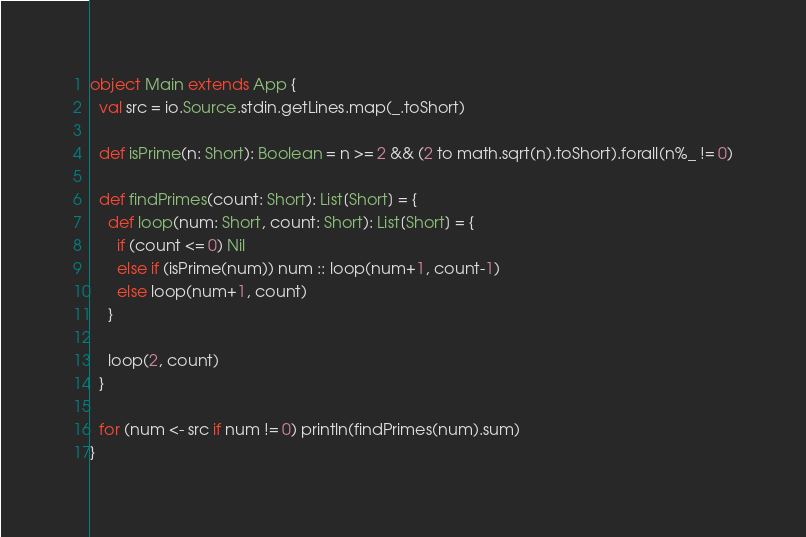<code> <loc_0><loc_0><loc_500><loc_500><_Scala_>object Main extends App {
  val src = io.Source.stdin.getLines.map(_.toShort)

  def isPrime(n: Short): Boolean = n >= 2 && (2 to math.sqrt(n).toShort).forall(n%_ != 0)

  def findPrimes(count: Short): List[Short] = {
    def loop(num: Short, count: Short): List[Short] = {
      if (count <= 0) Nil
      else if (isPrime(num)) num :: loop(num+1, count-1)
      else loop(num+1, count)
    }

    loop(2, count)
  }

  for (num <- src if num != 0) println(findPrimes(num).sum)
}</code> 